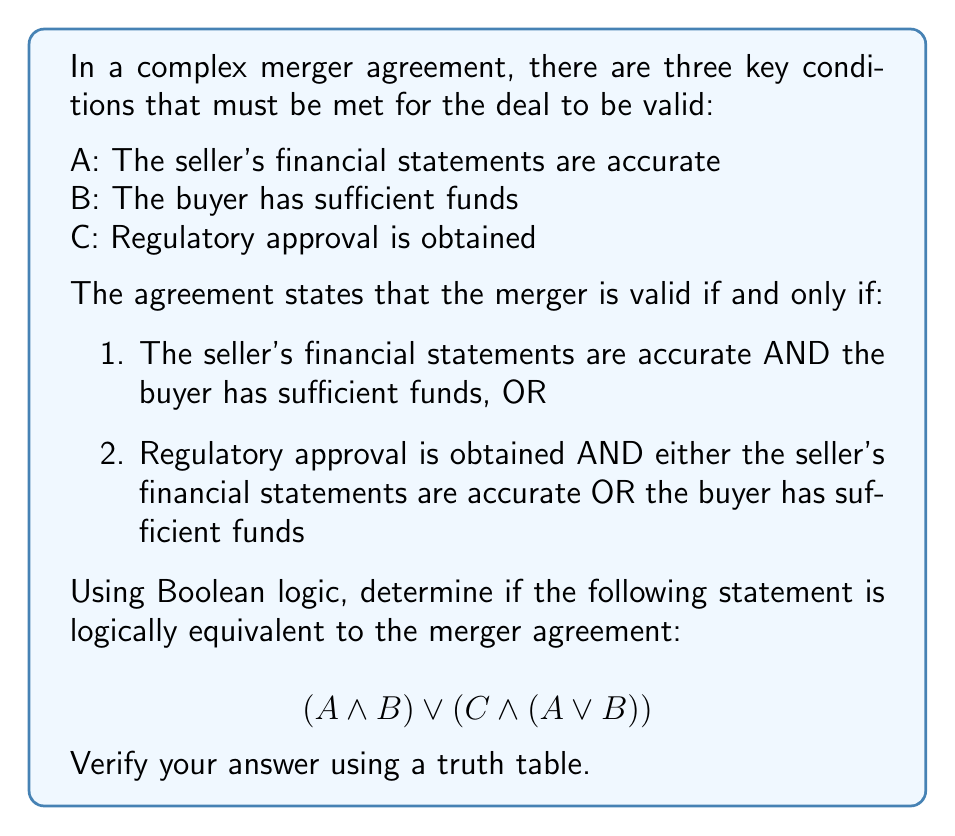Give your solution to this math problem. To determine if the given Boolean expression is logically equivalent to the merger agreement, we need to follow these steps:

1) First, let's express the merger agreement conditions in Boolean logic:
   Condition 1: $A \land B$
   Condition 2: $C \land (A \lor B)$

   The full expression for the merger agreement is:
   $$(A \land B) \lor (C \land (A \lor B))$$

2) We can see that this is exactly the same as the given expression in the question. However, to verify this conclusively, we need to create a truth table.

3) Creating the truth table:

   $$\begin{array}{|c|c|c|c|c|c|}
   \hline
   A & B & C & A \land B & C \land (A \lor B) & (A \land B) \lor (C \land (A \lor B)) \\
   \hline
   0 & 0 & 0 & 0 & 0 & 0 \\
   0 & 0 & 1 & 0 & 0 & 0 \\
   0 & 1 & 0 & 0 & 0 & 0 \\
   0 & 1 & 1 & 0 & 1 & 1 \\
   1 & 0 & 0 & 0 & 0 & 0 \\
   1 & 0 & 1 & 0 & 1 & 1 \\
   1 & 1 & 0 & 1 & 0 & 1 \\
   1 & 1 & 1 & 1 & 1 & 1 \\
   \hline
   \end{array}$$

4) From the truth table, we can see that the final column represents all possible outcomes of the merger agreement. The expression is true (1) when:
   - Both A and B are true (regardless of C)
   - C is true and either A or B (or both) are true

5) This matches exactly with the conditions stated in the merger agreement.

Therefore, the given Boolean expression $$(A \land B) \lor (C \land (A \lor B))$$ is indeed logically equivalent to the merger agreement.
Answer: Yes, logically equivalent 